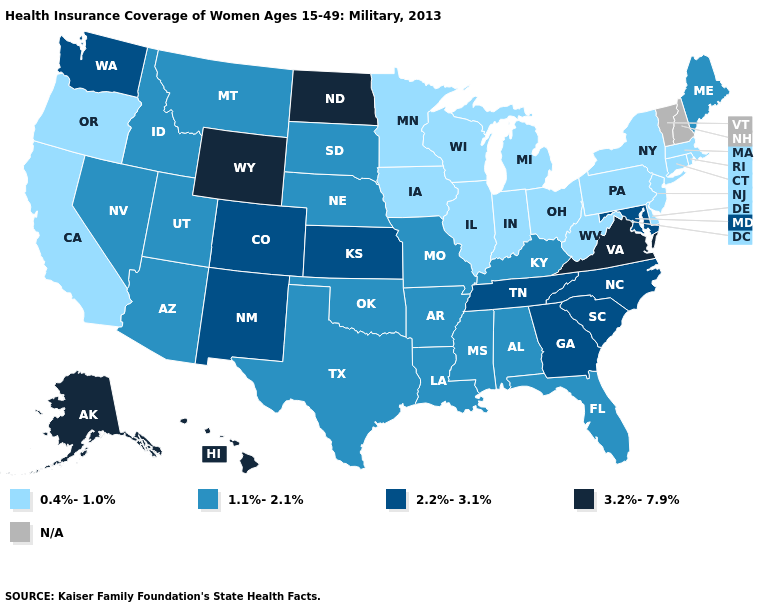What is the value of Colorado?
Keep it brief. 2.2%-3.1%. What is the value of California?
Concise answer only. 0.4%-1.0%. Name the states that have a value in the range 1.1%-2.1%?
Concise answer only. Alabama, Arizona, Arkansas, Florida, Idaho, Kentucky, Louisiana, Maine, Mississippi, Missouri, Montana, Nebraska, Nevada, Oklahoma, South Dakota, Texas, Utah. What is the value of Hawaii?
Short answer required. 3.2%-7.9%. Does Wyoming have the highest value in the USA?
Write a very short answer. Yes. Name the states that have a value in the range N/A?
Answer briefly. New Hampshire, Vermont. Which states have the lowest value in the South?
Be succinct. Delaware, West Virginia. What is the value of Kansas?
Concise answer only. 2.2%-3.1%. What is the value of Oregon?
Keep it brief. 0.4%-1.0%. Which states have the highest value in the USA?
Give a very brief answer. Alaska, Hawaii, North Dakota, Virginia, Wyoming. Name the states that have a value in the range 0.4%-1.0%?
Be succinct. California, Connecticut, Delaware, Illinois, Indiana, Iowa, Massachusetts, Michigan, Minnesota, New Jersey, New York, Ohio, Oregon, Pennsylvania, Rhode Island, West Virginia, Wisconsin. Does the map have missing data?
Keep it brief. Yes. What is the value of New Mexico?
Concise answer only. 2.2%-3.1%. 